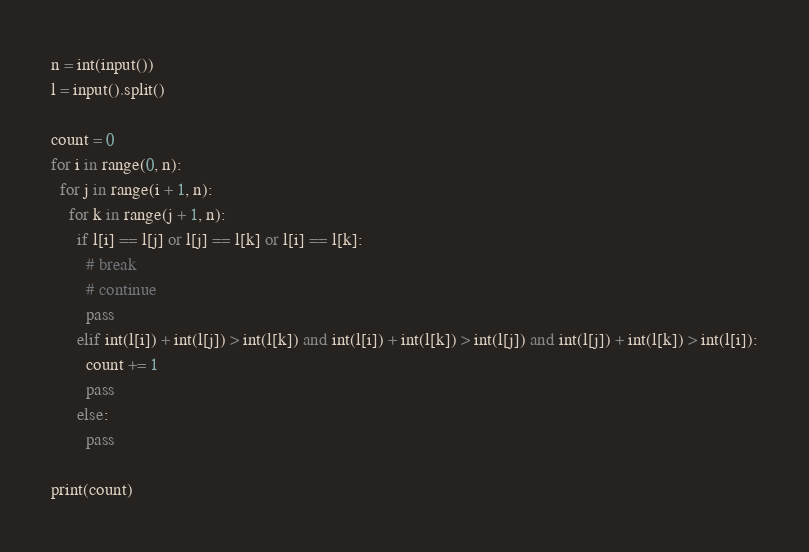<code> <loc_0><loc_0><loc_500><loc_500><_Python_>n = int(input())
l = input().split()

count = 0
for i in range(0, n):
  for j in range(i + 1, n):
    for k in range(j + 1, n):
      if l[i] == l[j] or l[j] == l[k] or l[i] == l[k]:
        # break
        # continue
        pass
      elif int(l[i]) + int(l[j]) > int(l[k]) and int(l[i]) + int(l[k]) > int(l[j]) and int(l[j]) + int(l[k]) > int(l[i]):
        count += 1
        pass
      else:
        pass

print(count)</code> 